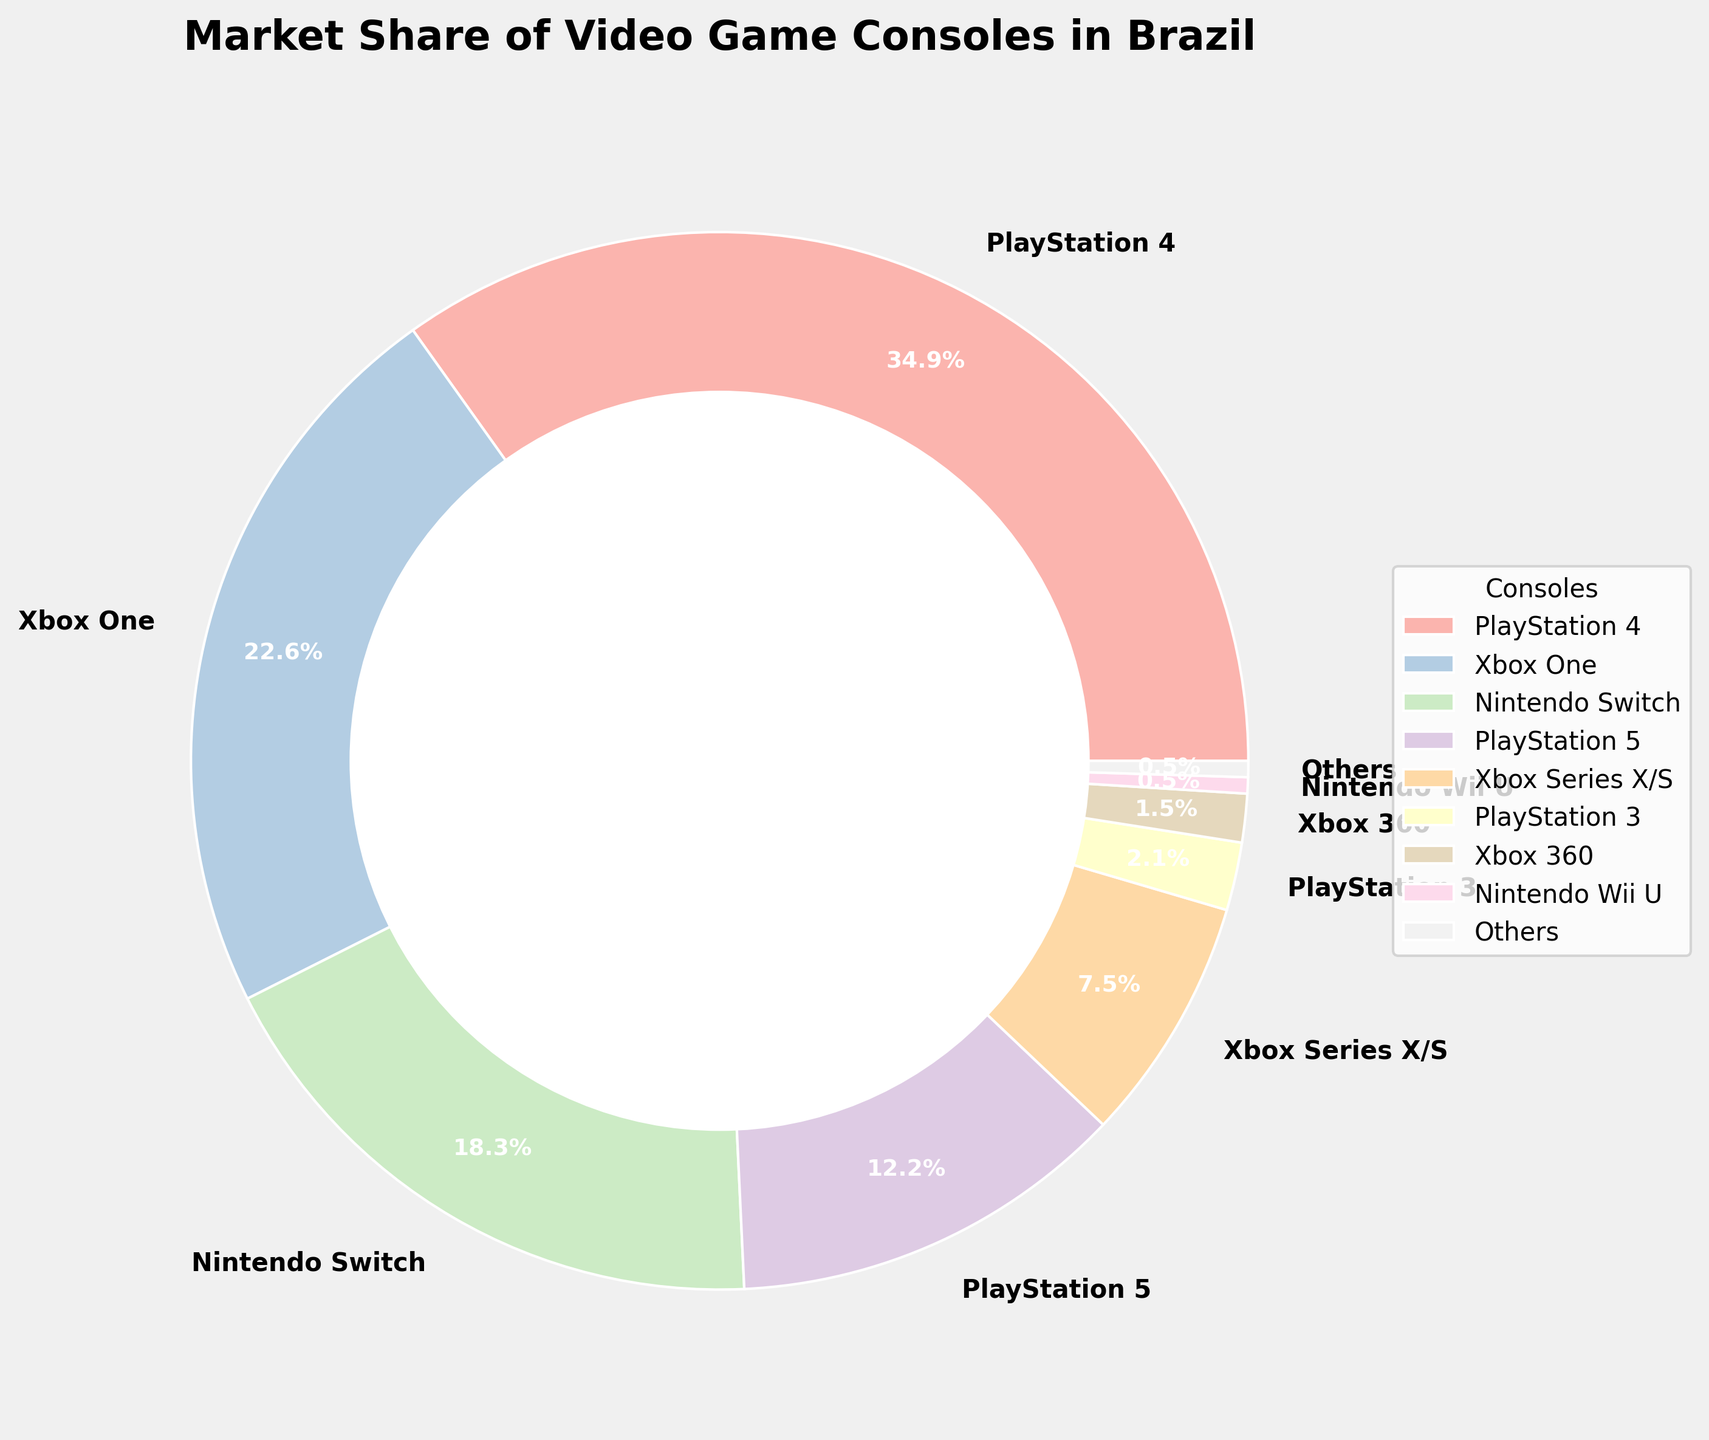which console has the highest market share? To determine which console has the highest market share, we look at the slices of the pie chart and find the one labeled with the highest percentage. PlayStation 4 is labeled with 35.2%, which is the highest among all the consoles.
Answer: PlayStation 4 what is the market share of PlayStation 5? Locate the slice labeled PlayStation 5 in the pie chart. The label indicates 12.3%, which is the market share for PlayStation 5.
Answer: 12.3% how does the market share of Nintendo Switch compare to Xbox One? Find and compare the labels for Nintendo Switch and Xbox One in the pie chart. The Nintendo Switch has a market share of 18.5%, while the Xbox One has 22.8%. Thus, Xbox One has a higher market share than Nintendo Switch.
Answer: Xbox One has a higher market share what is the combined market share of older consoles (PlayStation 3, Xbox 360, Nintendo Wii U)? Add the market shares of PlayStation 3, Xbox 360, and Nintendo Wii U. Based on the chart, PlayStation 3 has 2.1%, Xbox 360 has 1.5%, and Nintendo Wii U has 0.5%. The combined share is 2.1% + 1.5% + 0.5% = 4.1%.
Answer: 4.1% what is the difference in market share between PlayStation 4 and PlayStation 5? Subtract the market share of PlayStation 5 from the market share of PlayStation 4. PlayStation 4 has 35.2%, and PlayStation 5 has 12.3%. Therefore, 35.2% - 12.3% = 22.9%.
Answer: 22.9% which console has the smallest market share? Find the smallest percentage labeled on the pie chart. Both Nintendo Wii U and Others have the smallest share at 0.5%.
Answer: Nintendo Wii U and Others what percentage of the market is captured by the latest generation consoles (PlayStation 5 and Xbox Series X/S)? Add the market shares of PlayStation 5 and Xbox Series X/S. PlayStation 5 has 12.3% and Xbox Series X/S has 7.6%. So, 12.3% + 7.6% = 19.9%.
Answer: 19.9% what are the top three consoles in terms of market share and their combined share? Identify the top three consoles by their market share percentages: PlayStation 4 (35.2%), Xbox One (22.8%), and Nintendo Switch (18.5%). Add their shares: 35.2% + 22.8% + 18.5% = 76.5%.
Answer: PlayStation 4, Xbox One, Nintendo Switch, 76.5% how much greater is the market share of the top console compared to the combined share of Xbox 360 and Nintendo Wii U? First, find the market share of the top console, PlayStation 4, which is 35.2%. Next, find the combined share of Xbox 360 (1.5%) and Nintendo Wii U (0.5%), which is 1.5% + 0.5% = 2%. Subtract the combined share from the top console's share: 35.2% - 2% = 33.2%.
Answer: 33.2% how does the market share of "Others" compare to the lowest market share among the listed major consoles? Identify and compare the market share of "Others" and the lowest among the listed major consoles. "Others" and Nintendo Wii U both have 0.5%, so they share an equal market percentage.
Answer: Equal at 0.5% 